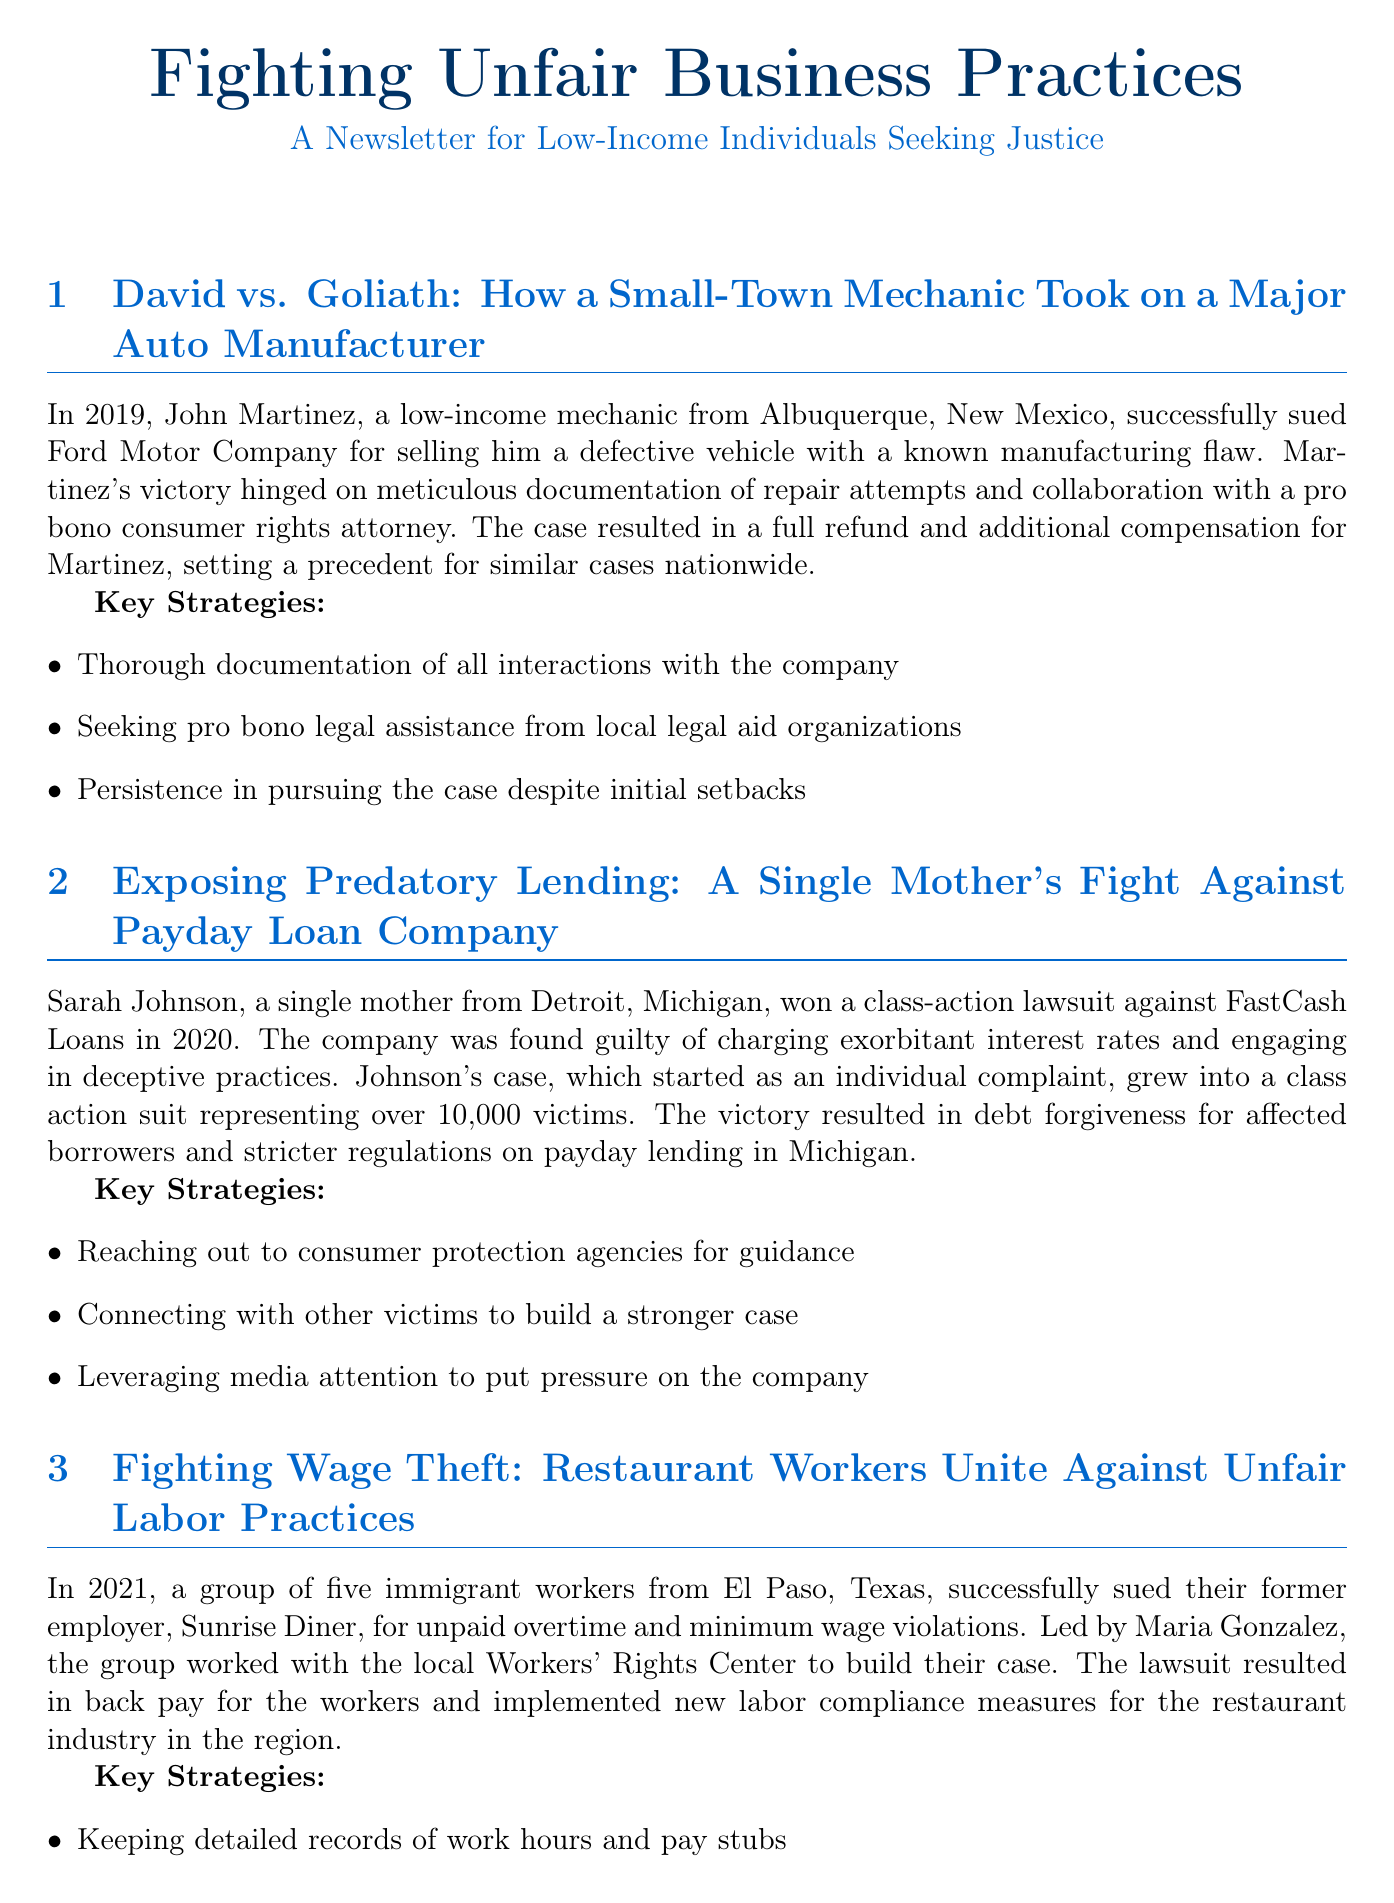What was the defect in John Martinez's vehicle? The document states that John Martinez's vehicle had a known manufacturing flaw sold by Ford Motor Company.
Answer: manufacturing flaw How many victims were represented in Sarah Johnson's class-action suit? The document mentions that Sarah Johnson's case grew to represent over 10,000 victims.
Answer: 10,000 What year did Robert Chen win his small claims court case? The document indicates that Robert Chen won his case against FitLife Gyms in 2018.
Answer: 2018 Which organization helped the group of restaurant workers in El Paso? The document mentions that the group collaborated with the local Workers' Rights Center.
Answer: Workers' Rights Center What was a key strategy used by John Martinez in his case? The document lists thorough documentation of all interactions with the company as a key strategy.
Answer: Thorough documentation What was the impact of the lawsuit led by Sarah Johnson? The document notes that the lawsuit resulted in debt forgiveness for affected borrowers and stricter regulations.
Answer: Debt forgiveness and stricter regulations What type of resources are listed at the end of the document? The document provides a list of resources available for low-income individuals seeking legal help.
Answer: Legal resources What type of document is this? The document is described as a newsletter for low-income individuals seeking justice.
Answer: newsletter 